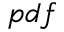<formula> <loc_0><loc_0><loc_500><loc_500>p d f</formula> 